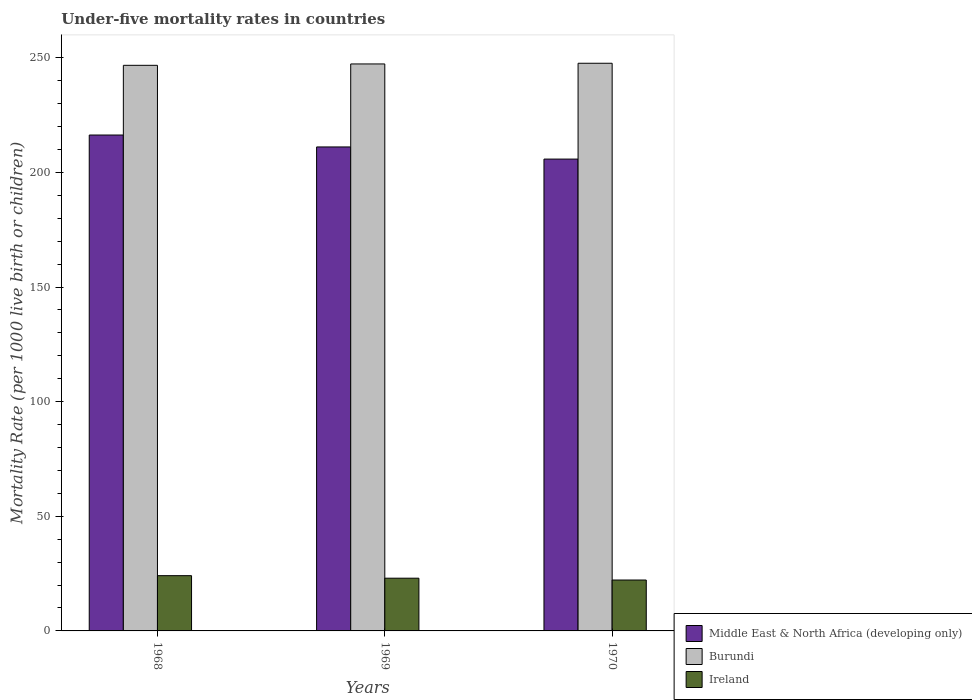How many different coloured bars are there?
Give a very brief answer. 3. Are the number of bars per tick equal to the number of legend labels?
Your response must be concise. Yes. What is the label of the 1st group of bars from the left?
Give a very brief answer. 1968. In how many cases, is the number of bars for a given year not equal to the number of legend labels?
Your response must be concise. 0. What is the under-five mortality rate in Burundi in 1968?
Ensure brevity in your answer.  246.7. Across all years, what is the maximum under-five mortality rate in Burundi?
Ensure brevity in your answer.  247.6. Across all years, what is the minimum under-five mortality rate in Burundi?
Offer a very short reply. 246.7. In which year was the under-five mortality rate in Ireland maximum?
Make the answer very short. 1968. In which year was the under-five mortality rate in Middle East & North Africa (developing only) minimum?
Make the answer very short. 1970. What is the total under-five mortality rate in Ireland in the graph?
Your response must be concise. 69.3. What is the difference between the under-five mortality rate in Middle East & North Africa (developing only) in 1969 and that in 1970?
Your answer should be very brief. 5.3. What is the difference between the under-five mortality rate in Burundi in 1968 and the under-five mortality rate in Ireland in 1970?
Provide a short and direct response. 224.5. What is the average under-five mortality rate in Burundi per year?
Ensure brevity in your answer.  247.2. In the year 1970, what is the difference between the under-five mortality rate in Ireland and under-five mortality rate in Burundi?
Your answer should be compact. -225.4. What is the ratio of the under-five mortality rate in Ireland in 1968 to that in 1970?
Provide a succinct answer. 1.09. What is the difference between the highest and the second highest under-five mortality rate in Burundi?
Your response must be concise. 0.3. What is the difference between the highest and the lowest under-five mortality rate in Ireland?
Offer a terse response. 1.9. Is the sum of the under-five mortality rate in Middle East & North Africa (developing only) in 1969 and 1970 greater than the maximum under-five mortality rate in Burundi across all years?
Your answer should be very brief. Yes. What does the 2nd bar from the left in 1968 represents?
Offer a very short reply. Burundi. What does the 3rd bar from the right in 1969 represents?
Offer a terse response. Middle East & North Africa (developing only). How many bars are there?
Offer a very short reply. 9. How many years are there in the graph?
Give a very brief answer. 3. Does the graph contain any zero values?
Your response must be concise. No. How many legend labels are there?
Your response must be concise. 3. How are the legend labels stacked?
Keep it short and to the point. Vertical. What is the title of the graph?
Give a very brief answer. Under-five mortality rates in countries. Does "Ukraine" appear as one of the legend labels in the graph?
Your answer should be compact. No. What is the label or title of the X-axis?
Make the answer very short. Years. What is the label or title of the Y-axis?
Offer a very short reply. Mortality Rate (per 1000 live birth or children). What is the Mortality Rate (per 1000 live birth or children) of Middle East & North Africa (developing only) in 1968?
Keep it short and to the point. 216.3. What is the Mortality Rate (per 1000 live birth or children) in Burundi in 1968?
Your answer should be very brief. 246.7. What is the Mortality Rate (per 1000 live birth or children) in Ireland in 1968?
Your answer should be compact. 24.1. What is the Mortality Rate (per 1000 live birth or children) of Middle East & North Africa (developing only) in 1969?
Give a very brief answer. 211.1. What is the Mortality Rate (per 1000 live birth or children) in Burundi in 1969?
Your answer should be very brief. 247.3. What is the Mortality Rate (per 1000 live birth or children) in Ireland in 1969?
Provide a succinct answer. 23. What is the Mortality Rate (per 1000 live birth or children) of Middle East & North Africa (developing only) in 1970?
Offer a terse response. 205.8. What is the Mortality Rate (per 1000 live birth or children) in Burundi in 1970?
Provide a short and direct response. 247.6. Across all years, what is the maximum Mortality Rate (per 1000 live birth or children) in Middle East & North Africa (developing only)?
Give a very brief answer. 216.3. Across all years, what is the maximum Mortality Rate (per 1000 live birth or children) of Burundi?
Your response must be concise. 247.6. Across all years, what is the maximum Mortality Rate (per 1000 live birth or children) of Ireland?
Offer a very short reply. 24.1. Across all years, what is the minimum Mortality Rate (per 1000 live birth or children) of Middle East & North Africa (developing only)?
Offer a terse response. 205.8. Across all years, what is the minimum Mortality Rate (per 1000 live birth or children) in Burundi?
Offer a very short reply. 246.7. What is the total Mortality Rate (per 1000 live birth or children) of Middle East & North Africa (developing only) in the graph?
Offer a very short reply. 633.2. What is the total Mortality Rate (per 1000 live birth or children) of Burundi in the graph?
Your answer should be very brief. 741.6. What is the total Mortality Rate (per 1000 live birth or children) of Ireland in the graph?
Make the answer very short. 69.3. What is the difference between the Mortality Rate (per 1000 live birth or children) of Burundi in 1968 and that in 1969?
Your response must be concise. -0.6. What is the difference between the Mortality Rate (per 1000 live birth or children) in Middle East & North Africa (developing only) in 1968 and that in 1970?
Offer a terse response. 10.5. What is the difference between the Mortality Rate (per 1000 live birth or children) of Burundi in 1968 and that in 1970?
Offer a very short reply. -0.9. What is the difference between the Mortality Rate (per 1000 live birth or children) in Burundi in 1969 and that in 1970?
Ensure brevity in your answer.  -0.3. What is the difference between the Mortality Rate (per 1000 live birth or children) in Ireland in 1969 and that in 1970?
Ensure brevity in your answer.  0.8. What is the difference between the Mortality Rate (per 1000 live birth or children) in Middle East & North Africa (developing only) in 1968 and the Mortality Rate (per 1000 live birth or children) in Burundi in 1969?
Give a very brief answer. -31. What is the difference between the Mortality Rate (per 1000 live birth or children) in Middle East & North Africa (developing only) in 1968 and the Mortality Rate (per 1000 live birth or children) in Ireland in 1969?
Your answer should be very brief. 193.3. What is the difference between the Mortality Rate (per 1000 live birth or children) of Burundi in 1968 and the Mortality Rate (per 1000 live birth or children) of Ireland in 1969?
Your answer should be compact. 223.7. What is the difference between the Mortality Rate (per 1000 live birth or children) of Middle East & North Africa (developing only) in 1968 and the Mortality Rate (per 1000 live birth or children) of Burundi in 1970?
Your answer should be very brief. -31.3. What is the difference between the Mortality Rate (per 1000 live birth or children) of Middle East & North Africa (developing only) in 1968 and the Mortality Rate (per 1000 live birth or children) of Ireland in 1970?
Make the answer very short. 194.1. What is the difference between the Mortality Rate (per 1000 live birth or children) of Burundi in 1968 and the Mortality Rate (per 1000 live birth or children) of Ireland in 1970?
Give a very brief answer. 224.5. What is the difference between the Mortality Rate (per 1000 live birth or children) of Middle East & North Africa (developing only) in 1969 and the Mortality Rate (per 1000 live birth or children) of Burundi in 1970?
Give a very brief answer. -36.5. What is the difference between the Mortality Rate (per 1000 live birth or children) of Middle East & North Africa (developing only) in 1969 and the Mortality Rate (per 1000 live birth or children) of Ireland in 1970?
Your answer should be compact. 188.9. What is the difference between the Mortality Rate (per 1000 live birth or children) in Burundi in 1969 and the Mortality Rate (per 1000 live birth or children) in Ireland in 1970?
Your answer should be compact. 225.1. What is the average Mortality Rate (per 1000 live birth or children) in Middle East & North Africa (developing only) per year?
Your response must be concise. 211.07. What is the average Mortality Rate (per 1000 live birth or children) of Burundi per year?
Offer a terse response. 247.2. What is the average Mortality Rate (per 1000 live birth or children) in Ireland per year?
Your answer should be very brief. 23.1. In the year 1968, what is the difference between the Mortality Rate (per 1000 live birth or children) of Middle East & North Africa (developing only) and Mortality Rate (per 1000 live birth or children) of Burundi?
Your response must be concise. -30.4. In the year 1968, what is the difference between the Mortality Rate (per 1000 live birth or children) of Middle East & North Africa (developing only) and Mortality Rate (per 1000 live birth or children) of Ireland?
Keep it short and to the point. 192.2. In the year 1968, what is the difference between the Mortality Rate (per 1000 live birth or children) in Burundi and Mortality Rate (per 1000 live birth or children) in Ireland?
Offer a terse response. 222.6. In the year 1969, what is the difference between the Mortality Rate (per 1000 live birth or children) in Middle East & North Africa (developing only) and Mortality Rate (per 1000 live birth or children) in Burundi?
Offer a terse response. -36.2. In the year 1969, what is the difference between the Mortality Rate (per 1000 live birth or children) in Middle East & North Africa (developing only) and Mortality Rate (per 1000 live birth or children) in Ireland?
Your response must be concise. 188.1. In the year 1969, what is the difference between the Mortality Rate (per 1000 live birth or children) of Burundi and Mortality Rate (per 1000 live birth or children) of Ireland?
Your answer should be very brief. 224.3. In the year 1970, what is the difference between the Mortality Rate (per 1000 live birth or children) of Middle East & North Africa (developing only) and Mortality Rate (per 1000 live birth or children) of Burundi?
Ensure brevity in your answer.  -41.8. In the year 1970, what is the difference between the Mortality Rate (per 1000 live birth or children) of Middle East & North Africa (developing only) and Mortality Rate (per 1000 live birth or children) of Ireland?
Offer a terse response. 183.6. In the year 1970, what is the difference between the Mortality Rate (per 1000 live birth or children) of Burundi and Mortality Rate (per 1000 live birth or children) of Ireland?
Offer a very short reply. 225.4. What is the ratio of the Mortality Rate (per 1000 live birth or children) in Middle East & North Africa (developing only) in 1968 to that in 1969?
Provide a succinct answer. 1.02. What is the ratio of the Mortality Rate (per 1000 live birth or children) of Ireland in 1968 to that in 1969?
Keep it short and to the point. 1.05. What is the ratio of the Mortality Rate (per 1000 live birth or children) in Middle East & North Africa (developing only) in 1968 to that in 1970?
Provide a short and direct response. 1.05. What is the ratio of the Mortality Rate (per 1000 live birth or children) in Burundi in 1968 to that in 1970?
Provide a succinct answer. 1. What is the ratio of the Mortality Rate (per 1000 live birth or children) of Ireland in 1968 to that in 1970?
Keep it short and to the point. 1.09. What is the ratio of the Mortality Rate (per 1000 live birth or children) in Middle East & North Africa (developing only) in 1969 to that in 1970?
Your response must be concise. 1.03. What is the ratio of the Mortality Rate (per 1000 live birth or children) of Burundi in 1969 to that in 1970?
Make the answer very short. 1. What is the ratio of the Mortality Rate (per 1000 live birth or children) of Ireland in 1969 to that in 1970?
Your response must be concise. 1.04. What is the difference between the highest and the second highest Mortality Rate (per 1000 live birth or children) in Ireland?
Provide a short and direct response. 1.1. 